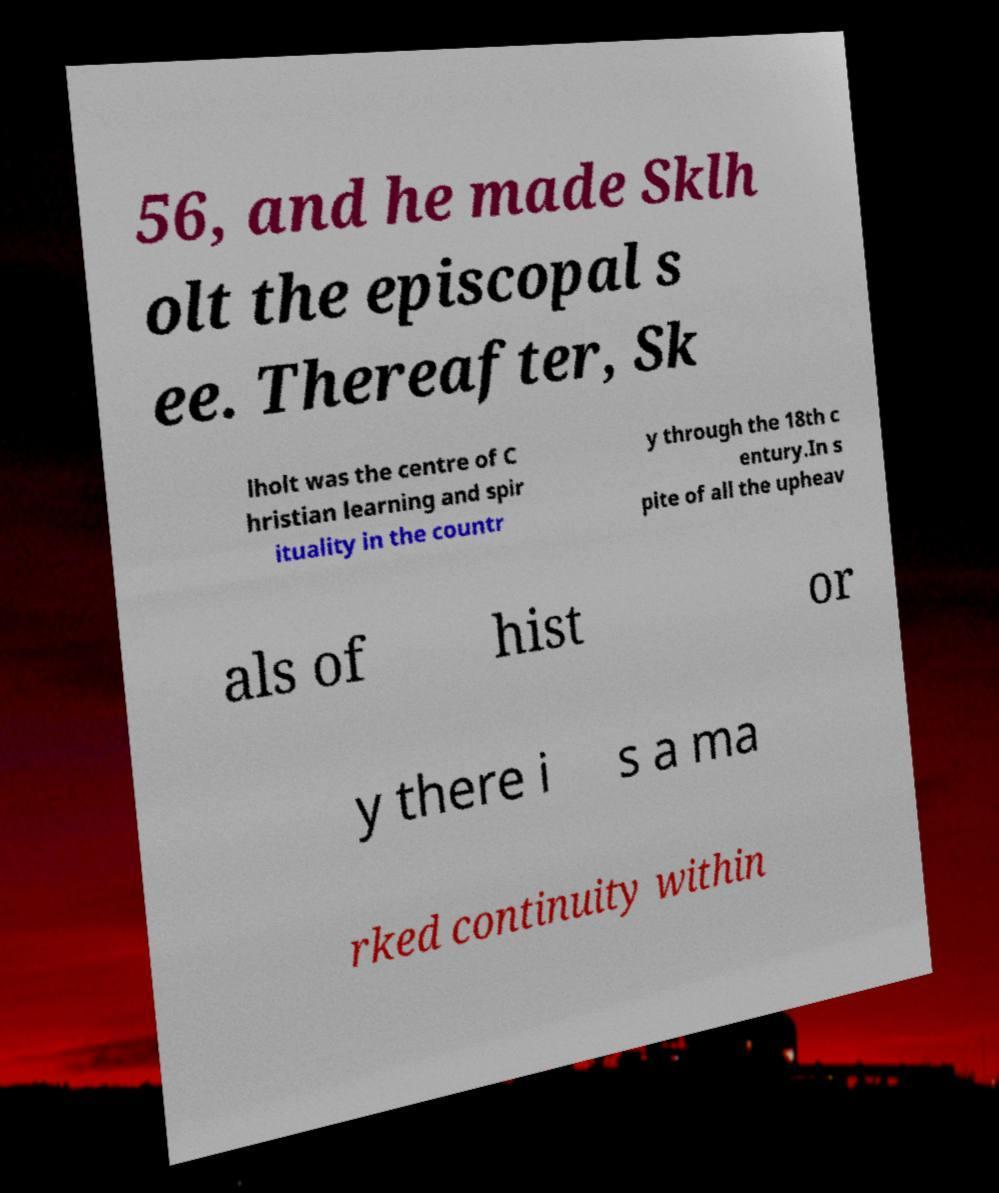There's text embedded in this image that I need extracted. Can you transcribe it verbatim? 56, and he made Sklh olt the episcopal s ee. Thereafter, Sk lholt was the centre of C hristian learning and spir ituality in the countr y through the 18th c entury.In s pite of all the upheav als of hist or y there i s a ma rked continuity within 